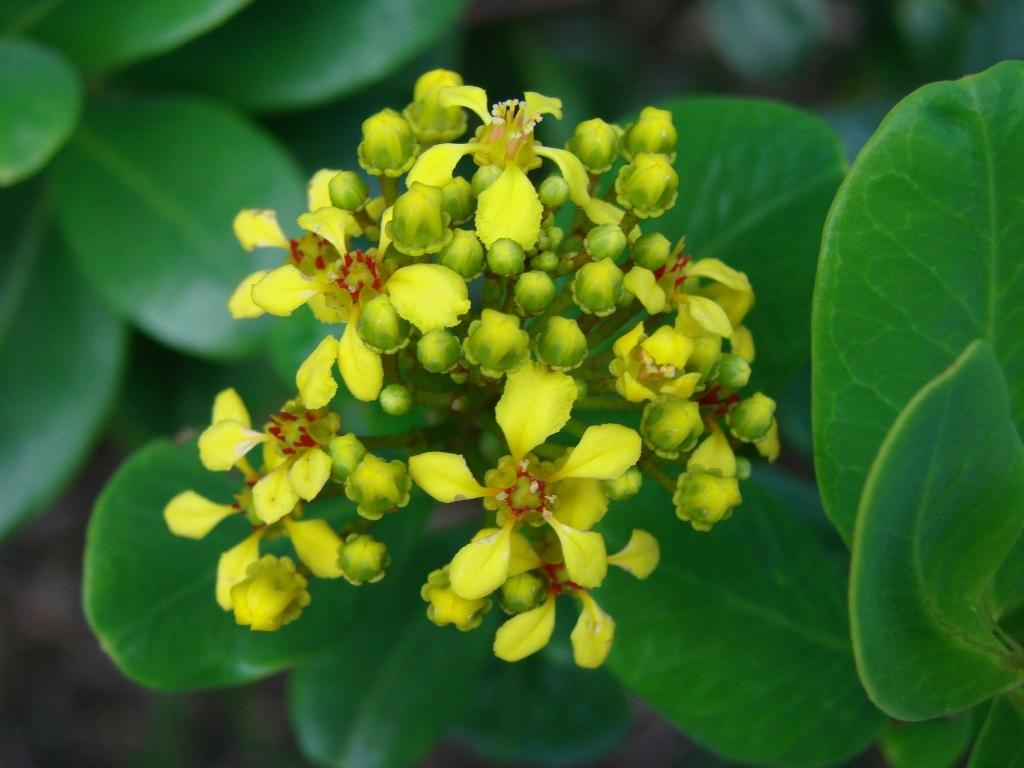What type of plant material can be seen in the image? There are leaves and flower buds in the image. Can you describe the stage of the flowers in the image? The flowers are in the bud stage, as they have not yet bloomed. What type of root can be seen growing from the flower buds in the image? There are no roots visible in the image; only leaves and flower buds can be seen. 